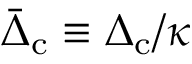Convert formula to latex. <formula><loc_0><loc_0><loc_500><loc_500>\bar { \Delta } _ { c } \equiv \Delta _ { c } / \kappa</formula> 